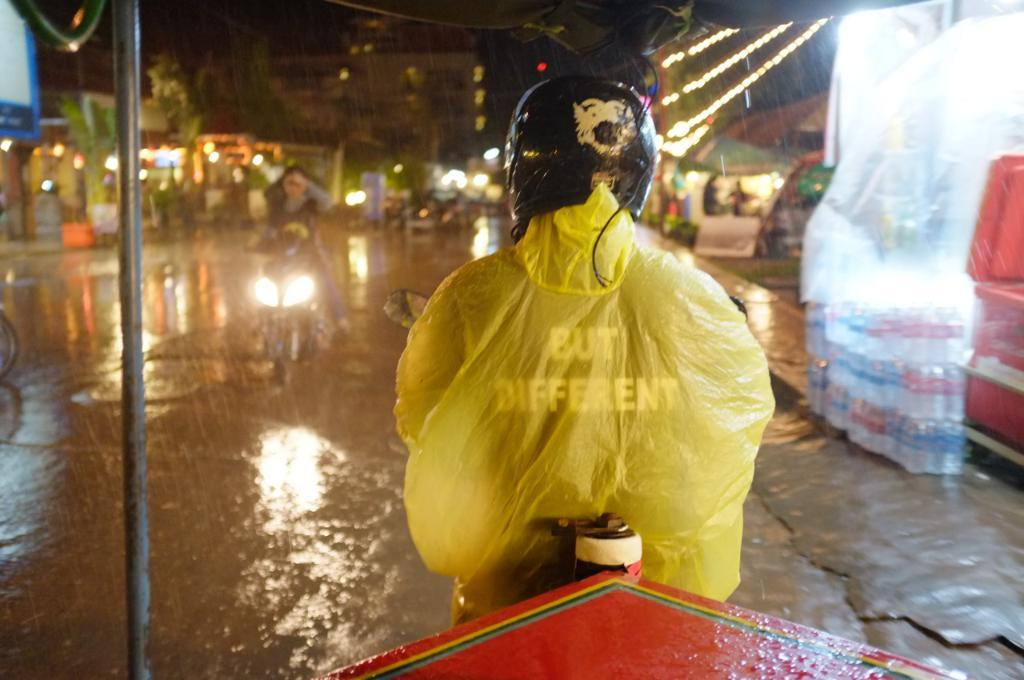What are the people in the image doing? The people in the image are riding bikes. What can be seen in the background of the image? There are buildings, trees, and lights in the background of the image. What is located on the right side of the image? There is a store on the right side of the image. What items can be seen in the store? Bottles are visible in the store. What additional feature is present in the image? There is a tent in the image. What type of voice can be heard coming from the tent in the image? There is no indication of any voice or sound coming from the tent in the image. What surprise is waiting for the people riding bikes in the image? There is no indication of any surprise or unexpected event happening to the people riding bikes in the image. 